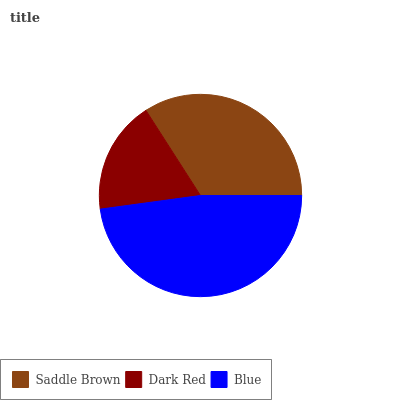Is Dark Red the minimum?
Answer yes or no. Yes. Is Blue the maximum?
Answer yes or no. Yes. Is Blue the minimum?
Answer yes or no. No. Is Dark Red the maximum?
Answer yes or no. No. Is Blue greater than Dark Red?
Answer yes or no. Yes. Is Dark Red less than Blue?
Answer yes or no. Yes. Is Dark Red greater than Blue?
Answer yes or no. No. Is Blue less than Dark Red?
Answer yes or no. No. Is Saddle Brown the high median?
Answer yes or no. Yes. Is Saddle Brown the low median?
Answer yes or no. Yes. Is Dark Red the high median?
Answer yes or no. No. Is Dark Red the low median?
Answer yes or no. No. 